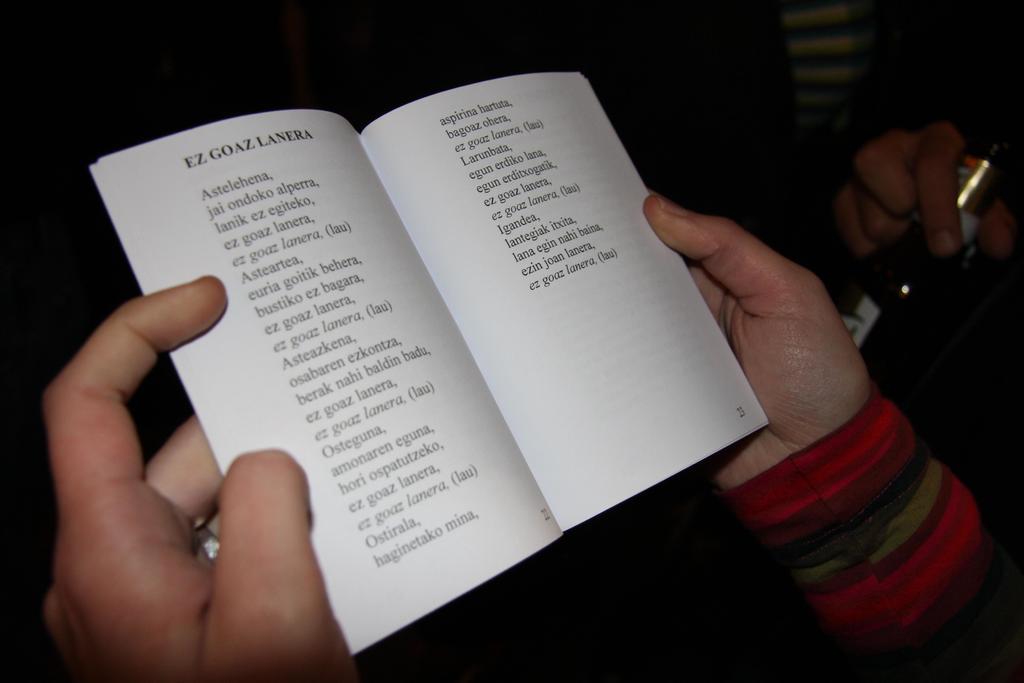What does the text in bold say?
Provide a succinct answer. Ez goaz lanera. 